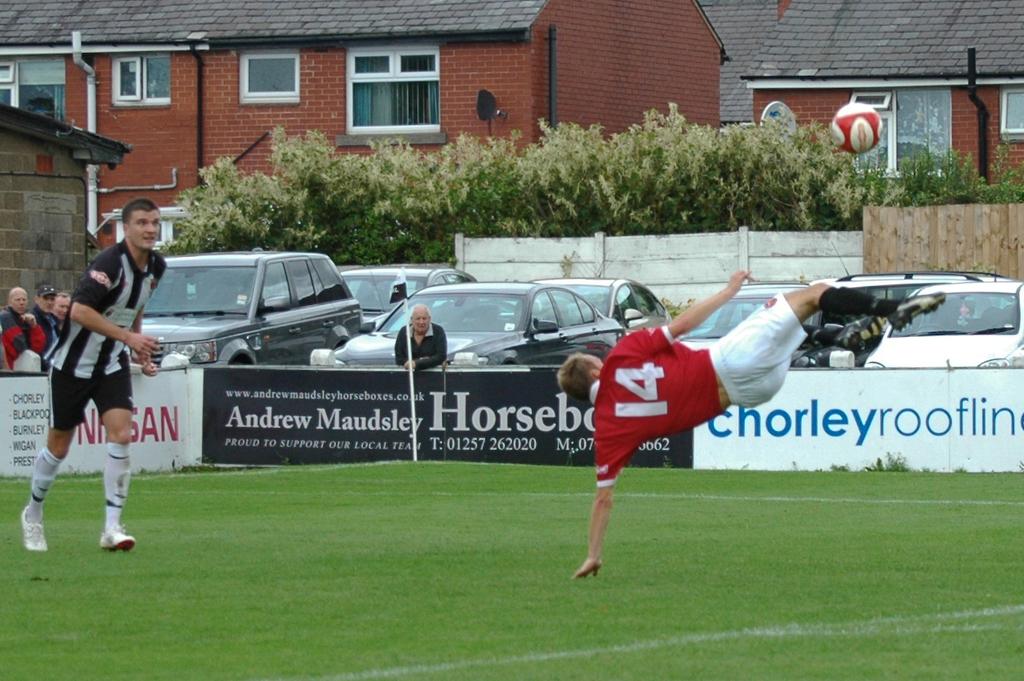What is the number of the player who just kicked the ball?
Your answer should be very brief. 14. Whose name is written on the billboard in the back with the black background?
Provide a short and direct response. Andrew maudsley. 